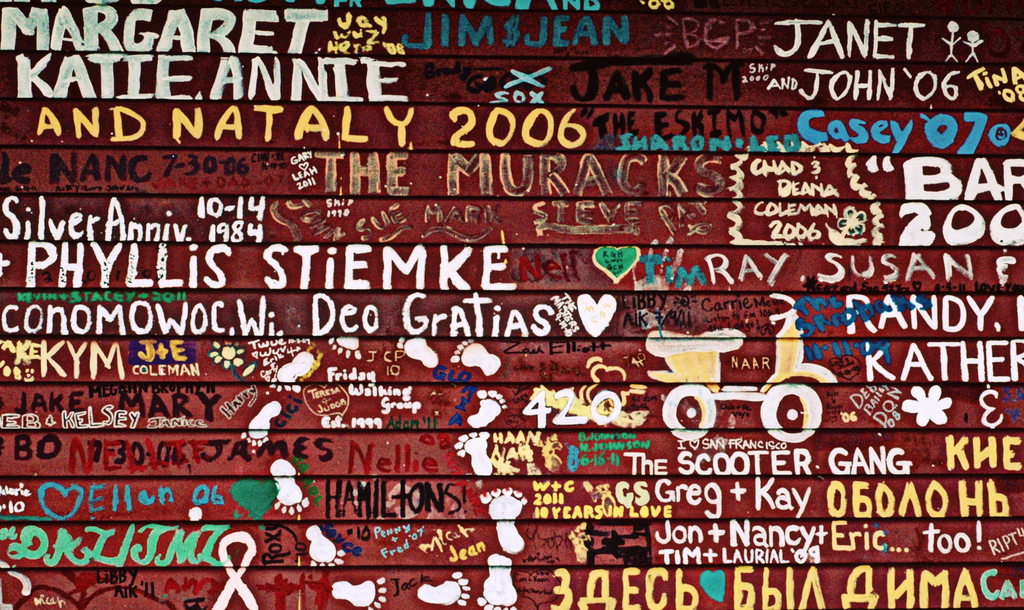Provide a one-sentence caption for the provided image. A vibrant graffiti wall densely packed with names and symbols, commemorating personal stories and events, indicating a lively social spot marked by messages of love and memory. 